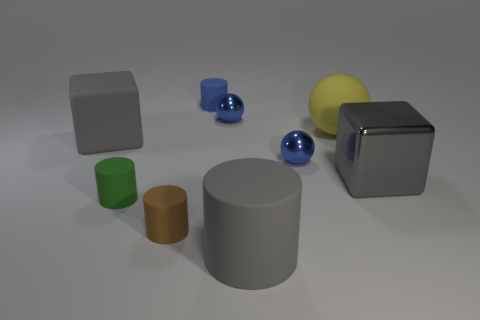Does the image give any indication of the size of these objects? The image does not provide a definitive scale for the size of the objects. However, they are depicted in relation to each other which suggests the gray cube and cylinder are the largest items, followed by the yellow sphere, the green and brown cylinders, and the smaller blue cylinders and sphere. 